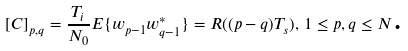Convert formula to latex. <formula><loc_0><loc_0><loc_500><loc_500>\left [ { C } \right ] _ { p , q } = \frac { T _ { i } } { N _ { 0 } } E \{ w _ { p - 1 } w _ { q - 1 } ^ { * } \} = R ( ( p - q ) T _ { s } ) , \, 1 \leq p , q \leq N \text  .</formula> 